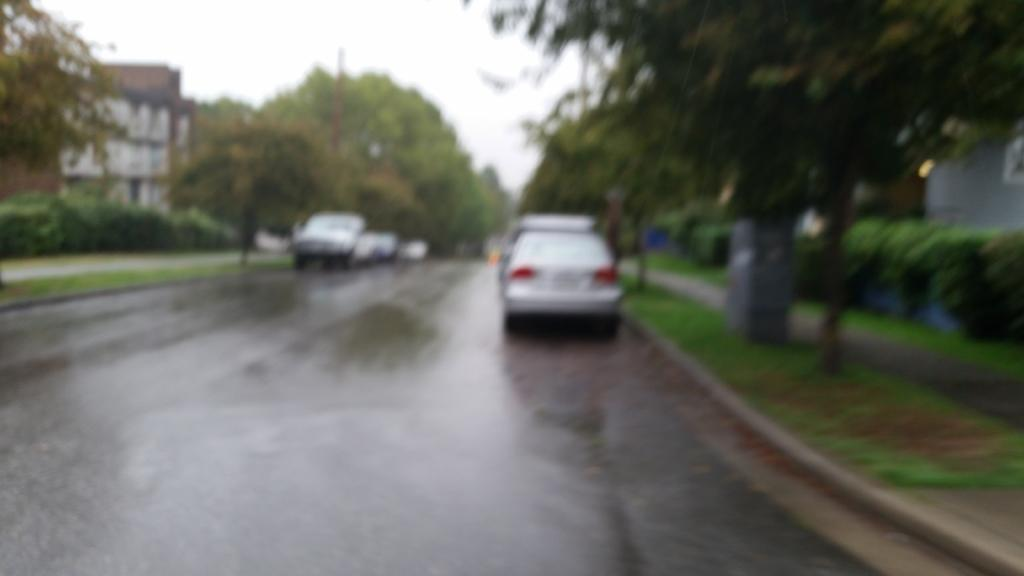What is the main subject of the image? The main subject of the image is vehicles on a road. What can be seen on either side of the road? There are trees and buildings on either side of the road. What is visible at the top of the image? The sky is visible at the top of the image. How many jars of jelly can be seen on the hill in the image? There is no hill or jelly present in the image. What type of route is depicted in the image? The image does not show a specific route; it simply shows vehicles on a road with trees and buildings on either side. 